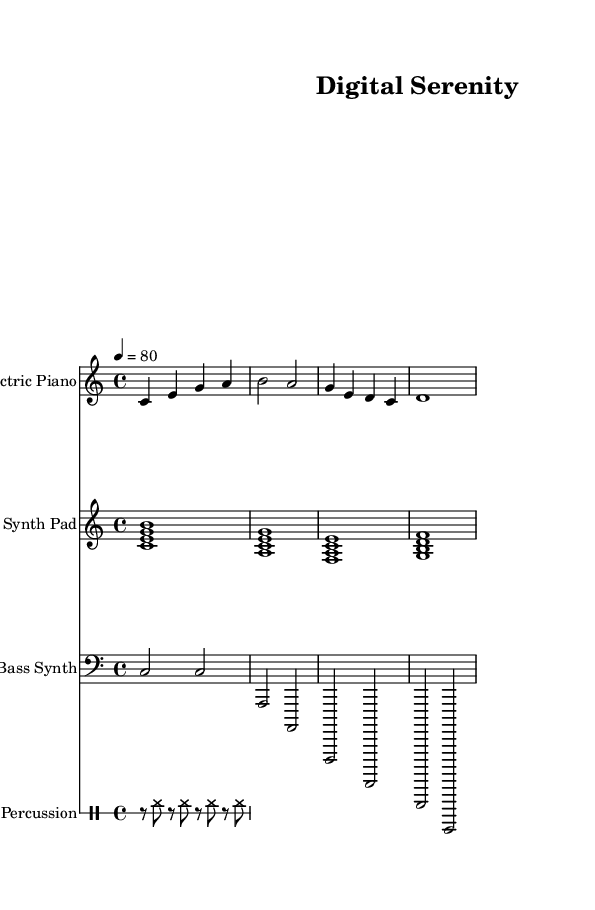What is the key signature of this music? The key signature is C major, which has no sharps or flats.
Answer: C major What is the time signature of this piece? The time signature is indicated at the beginning of the sheet music, showing 4 beats per measure, which is expressed as 4/4.
Answer: 4/4 What is the tempo marking in beats per minute? The tempo is indicated at the top of the score, stating the beats per minute as 80 beats.
Answer: 80 How many different instrumental parts are present in the composition? The score outlines four instrumental parts: Electric Piano, Synth Pad, Bass Synth, and Percussion. Each instrument is presented on a separate staff, totaling four.
Answer: Four Which instrument has the highest pitch range in this piece? By comparing the ranges of the provided staves, the Electric Piano plays the highest notes, starting from middle C upwards, while the Bass Synth primarily occupies lower pitches.
Answer: Electric Piano What type of electronic music is this sheet music categorized as? Given the characteristics and structure of the music, including its relaxing nature, the piece fits into the downtempo electronica genre, designed for unwinding and stress relief.
Answer: Downtempo electronica What is the rhythmic pattern of the percussion instrument? The rhythmic pattern for the percussion consists of alternating rests and hi-hat hits organized in eighth notes, indicating a steady, repetitive groove that supports the rest of the composition.
Answer: Hi-hat eighth notes 